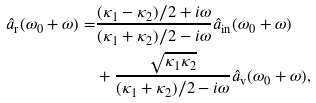Convert formula to latex. <formula><loc_0><loc_0><loc_500><loc_500>\hat { a } _ { \text {r} } ( \omega _ { 0 } + \omega ) = & \frac { ( \kappa _ { 1 } - \kappa _ { 2 } ) / 2 + i \omega } { ( \kappa _ { 1 } + \kappa _ { 2 } ) / 2 - i \omega } \hat { a } _ { \text {in} } ( \omega _ { 0 } + \omega ) \\ & + \frac { \sqrt { \kappa _ { 1 } \kappa _ { 2 } } } { ( \kappa _ { 1 } + \kappa _ { 2 } ) / 2 - i \omega } \hat { a } _ { \text {v} } ( \omega _ { 0 } + \omega ) ,</formula> 